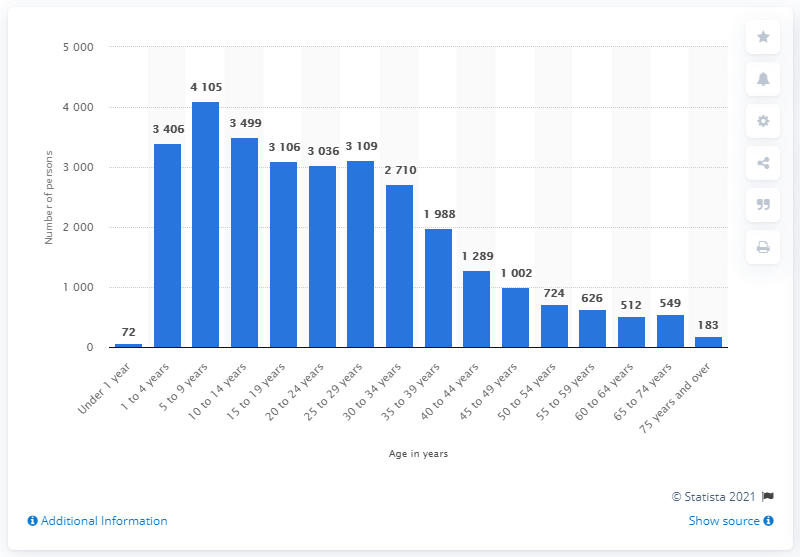Highlight a few significant elements in this photo. In 2019, 183 refugees arrived in the United States. 